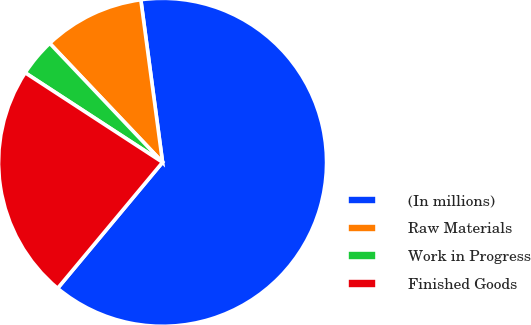<chart> <loc_0><loc_0><loc_500><loc_500><pie_chart><fcel>(In millions)<fcel>Raw Materials<fcel>Work in Progress<fcel>Finished Goods<nl><fcel>63.17%<fcel>9.96%<fcel>3.73%<fcel>23.14%<nl></chart> 